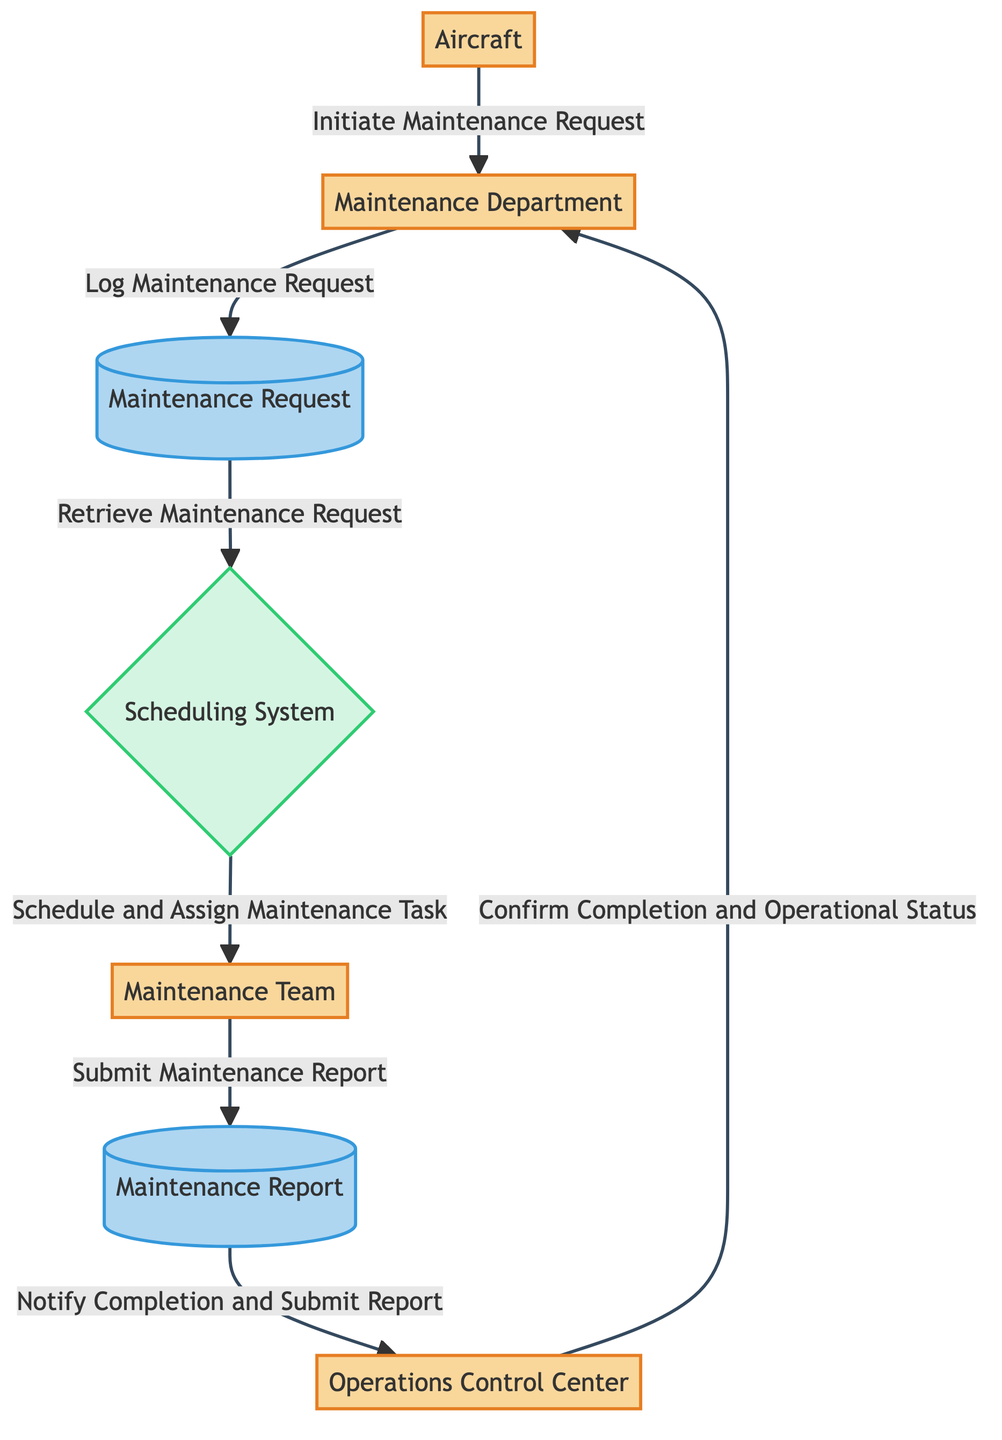What is the first entity to initiate the workflow? The diagram shows that the Aircraft is the first entity to initiate the workflow by sending a Maintenance Request to the Maintenance Department.
Answer: Aircraft How many external entities are present in the diagram? The diagram highlights four external entities: Aircraft, Maintenance Department, Maintenance Team, and Operations Control Center. Each serves a distinct role in the workflow.
Answer: Four What does the Maintenance Department do after receiving a Maintenance Request? After receiving it, the Maintenance Department logs the Maintenance Request into the Maintenance Request data store. This step is crucial for documentation and tracking.
Answer: Log Maintenance Request Which process is responsible for scheduling maintenance tasks? The Scheduling System is indicated in the diagram as the process responsible for scheduling and assigning maintenance tasks to the Maintenance Team. This is a key step in ensuring timely maintenance.
Answer: Scheduling System What data flow occurs from the Maintenance Report to the Operations Control Center? The diagram illustrates that the Maintenance Report is submitted to the Operations Control Center to notify them of completion and submit the report, indicating the maintenance status.
Answer: Notify Completion and Submit Report How do technicians update their maintenance status? Technicians from the Maintenance Team submit a Maintenance Report, which includes details of the performed maintenance and updates the current status of the aircraft. This ensures accurate and timely information flow.
Answer: Submit Maintenance Report What action does the Operations Control Center take after receiving the Maintenance Report? The Operations Control Center confirms completion and operational status back to the Maintenance Department, indicating that the maintenance was successful and the aircraft is ready for service.
Answer: Confirm Completion and Operational Status What is the final output of the workflow? The final output is the confirmation of completion and operational status communicated back to the Maintenance Department after all maintenance activities have been successfully recorded.
Answer: Confirm Completion and Operational Status 